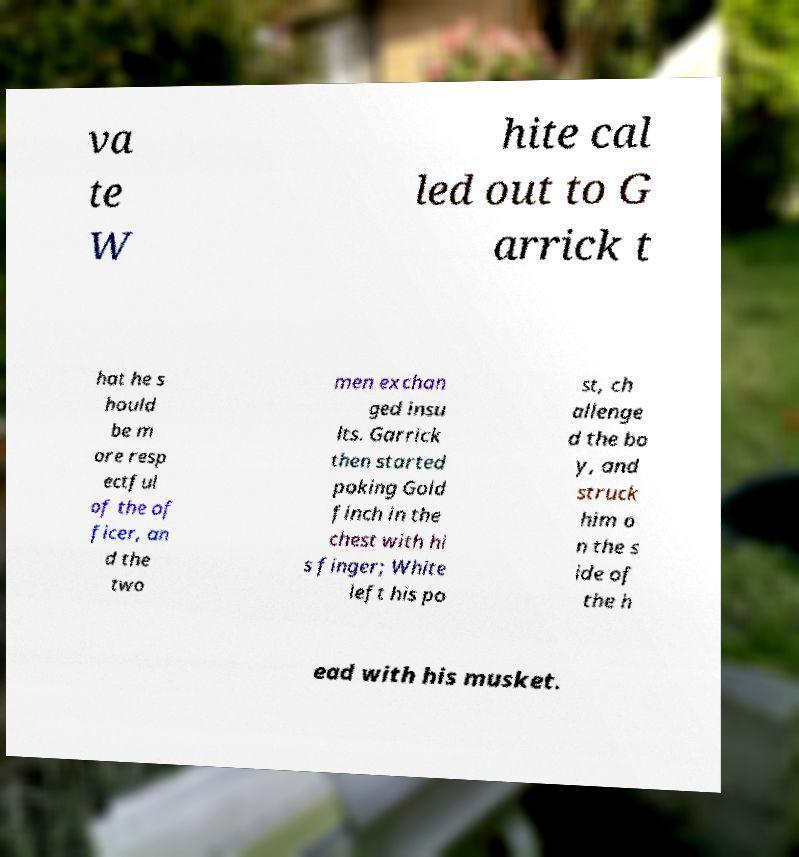Could you extract and type out the text from this image? va te W hite cal led out to G arrick t hat he s hould be m ore resp ectful of the of ficer, an d the two men exchan ged insu lts. Garrick then started poking Gold finch in the chest with hi s finger; White left his po st, ch allenge d the bo y, and struck him o n the s ide of the h ead with his musket. 